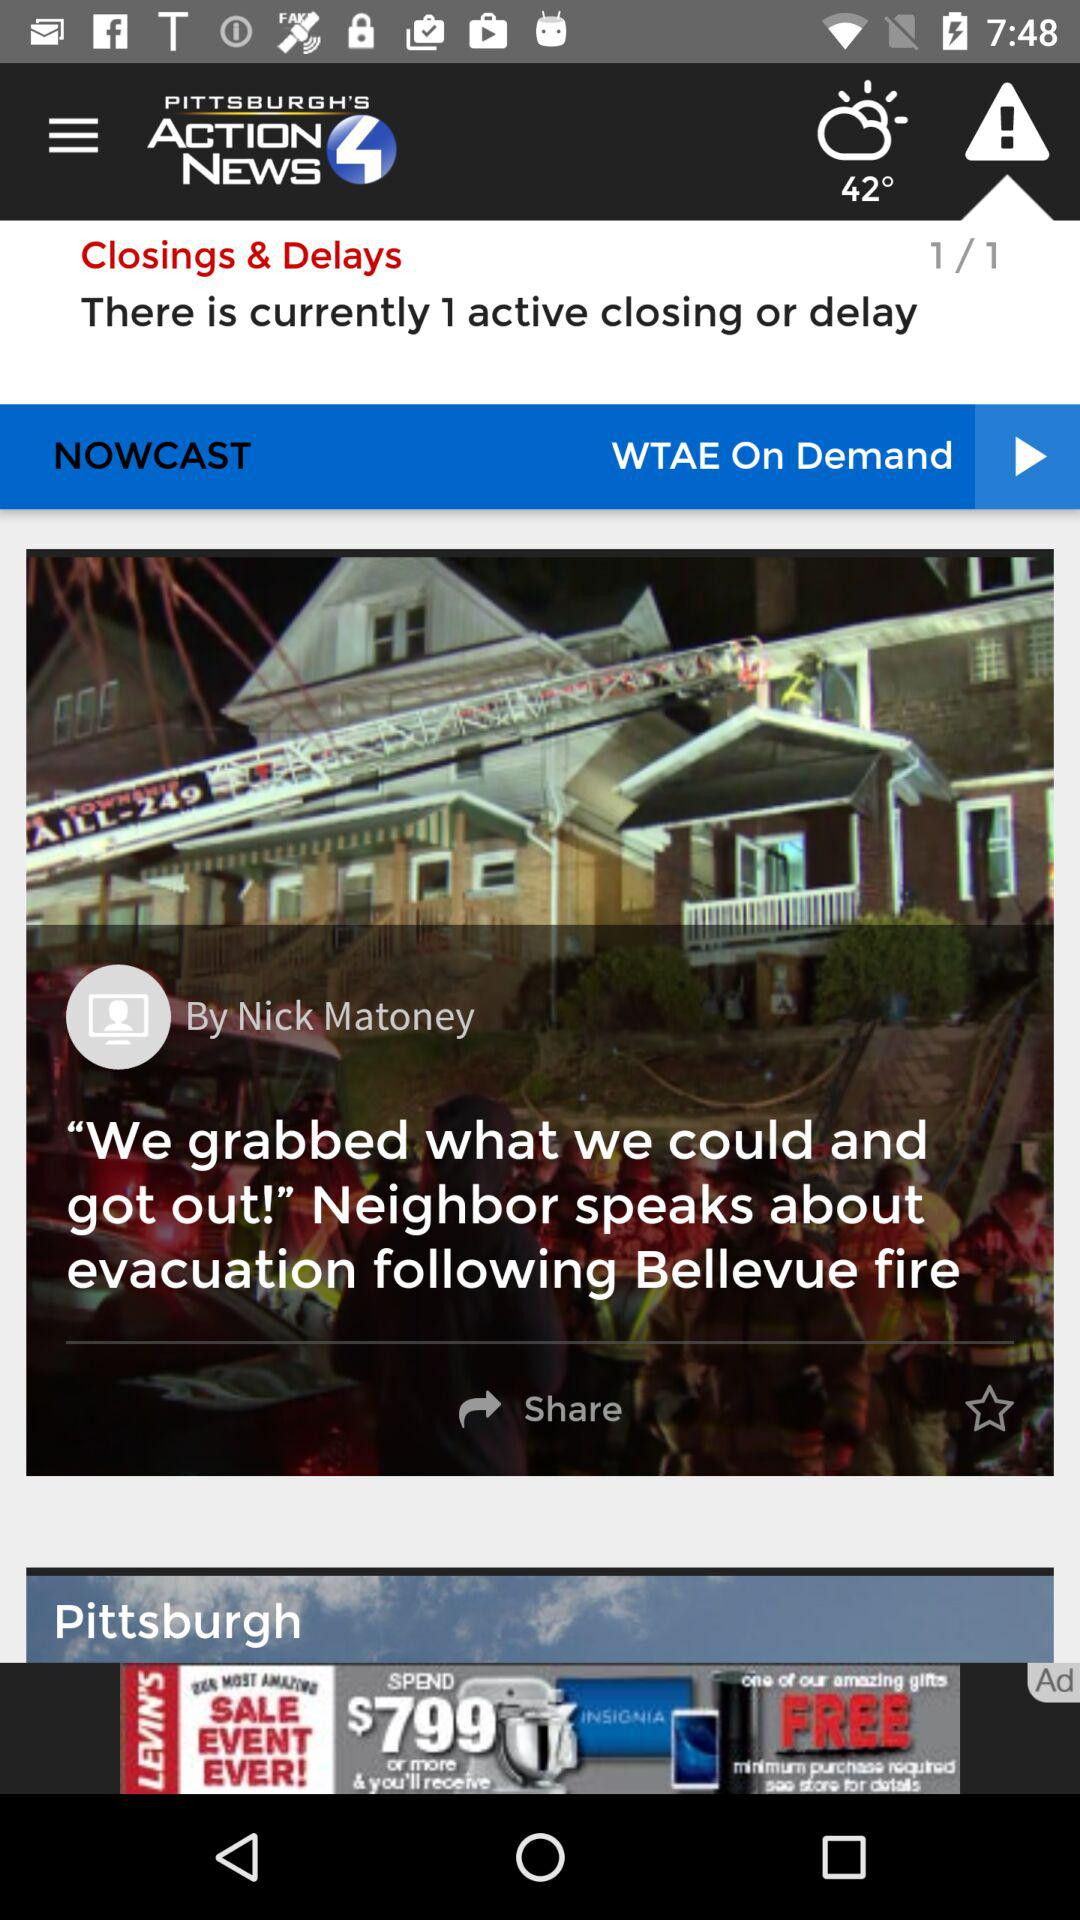How many "Closings & Delays" in total are there? There is one "Closings & Delays" in total. 